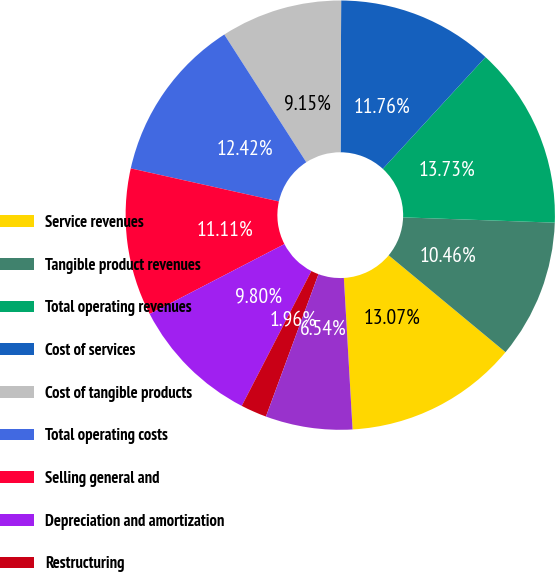Convert chart to OTSL. <chart><loc_0><loc_0><loc_500><loc_500><pie_chart><fcel>Service revenues<fcel>Tangible product revenues<fcel>Total operating revenues<fcel>Cost of services<fcel>Cost of tangible products<fcel>Total operating costs<fcel>Selling general and<fcel>Depreciation and amortization<fcel>Restructuring<fcel>(Income) expense from<nl><fcel>13.07%<fcel>10.46%<fcel>13.73%<fcel>11.76%<fcel>9.15%<fcel>12.42%<fcel>11.11%<fcel>9.8%<fcel>1.96%<fcel>6.54%<nl></chart> 